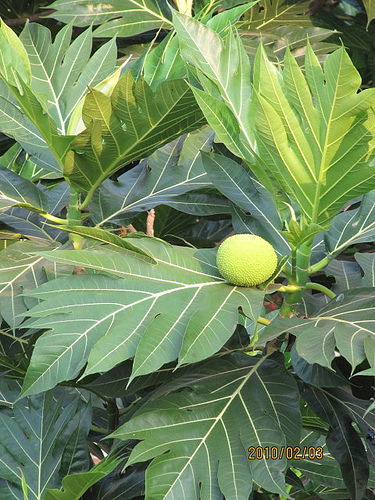<image>
Can you confirm if the leaf is above the fruit? Yes. The leaf is positioned above the fruit in the vertical space, higher up in the scene. 